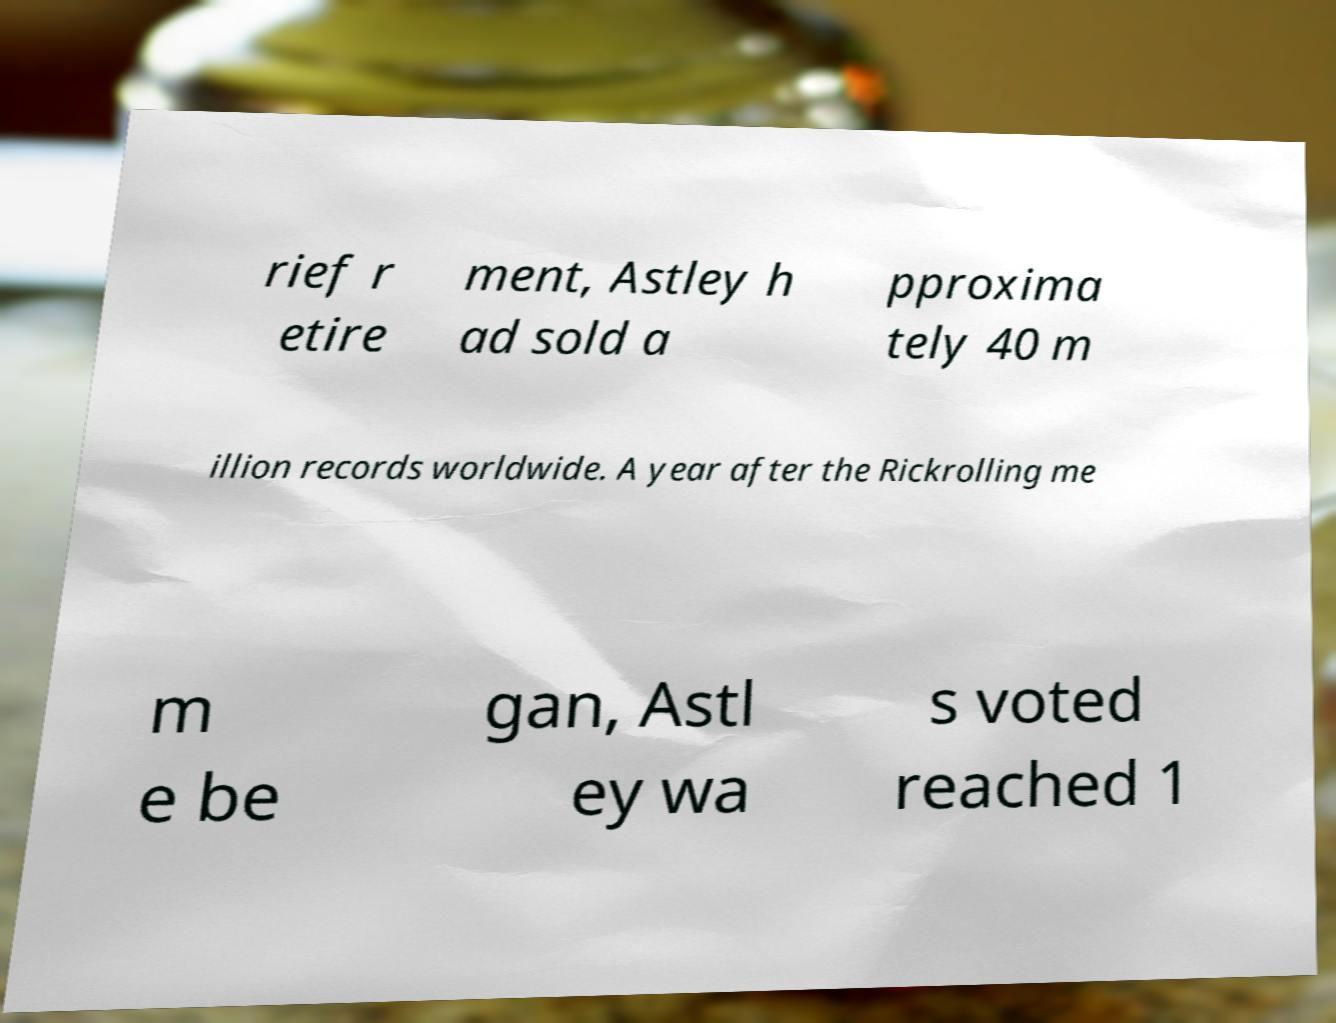Can you read and provide the text displayed in the image?This photo seems to have some interesting text. Can you extract and type it out for me? rief r etire ment, Astley h ad sold a pproxima tely 40 m illion records worldwide. A year after the Rickrolling me m e be gan, Astl ey wa s voted reached 1 